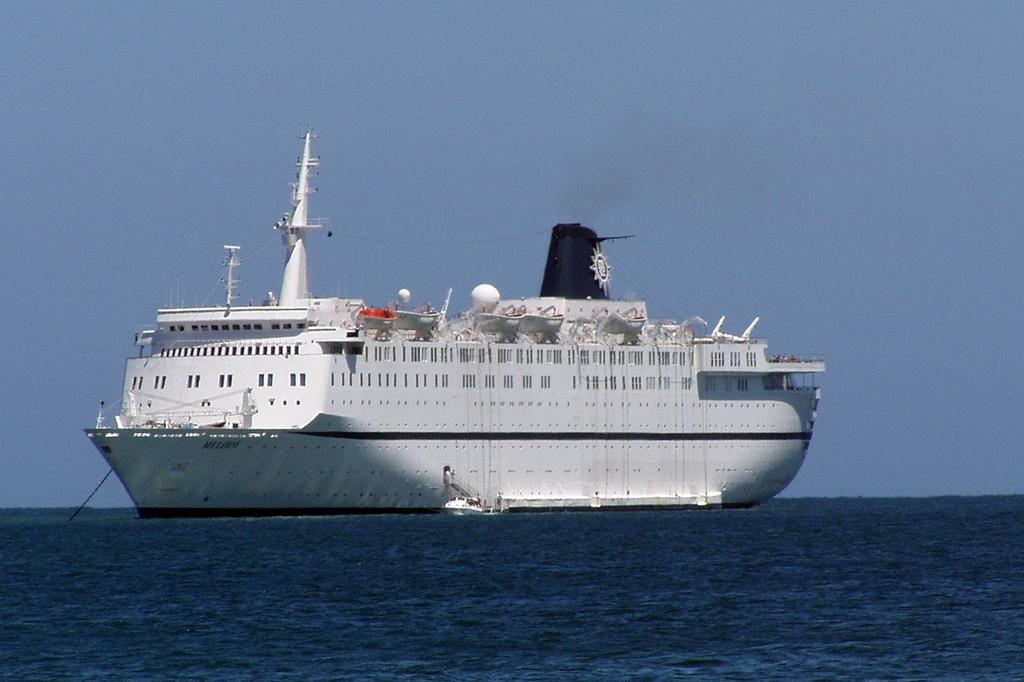What is the main subject of the picture? The main subject of the picture is a ship. Are there any additional features on the ship? Yes, there are objects attached to the ship. What type of environment is the ship located in? The ship is located in water, which is visible in the picture. What else can be seen in the background of the picture? The sky is visible in the picture. How many children are playing on the swing in the picture? There are no children or swings present in the image; it features a ship in water with objects attached to it. 